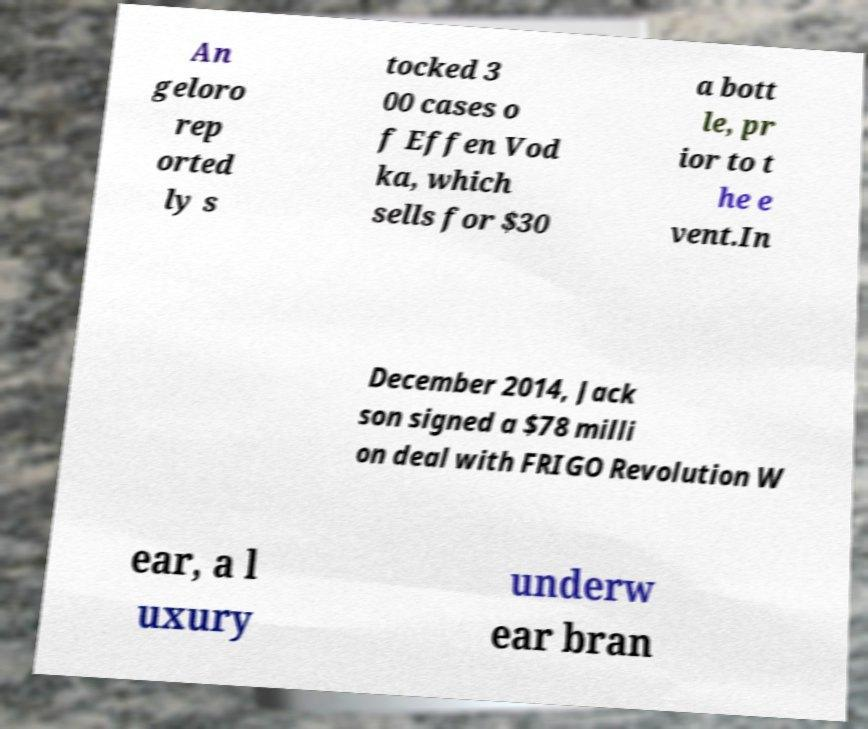Please read and relay the text visible in this image. What does it say? An geloro rep orted ly s tocked 3 00 cases o f Effen Vod ka, which sells for $30 a bott le, pr ior to t he e vent.In December 2014, Jack son signed a $78 milli on deal with FRIGO Revolution W ear, a l uxury underw ear bran 